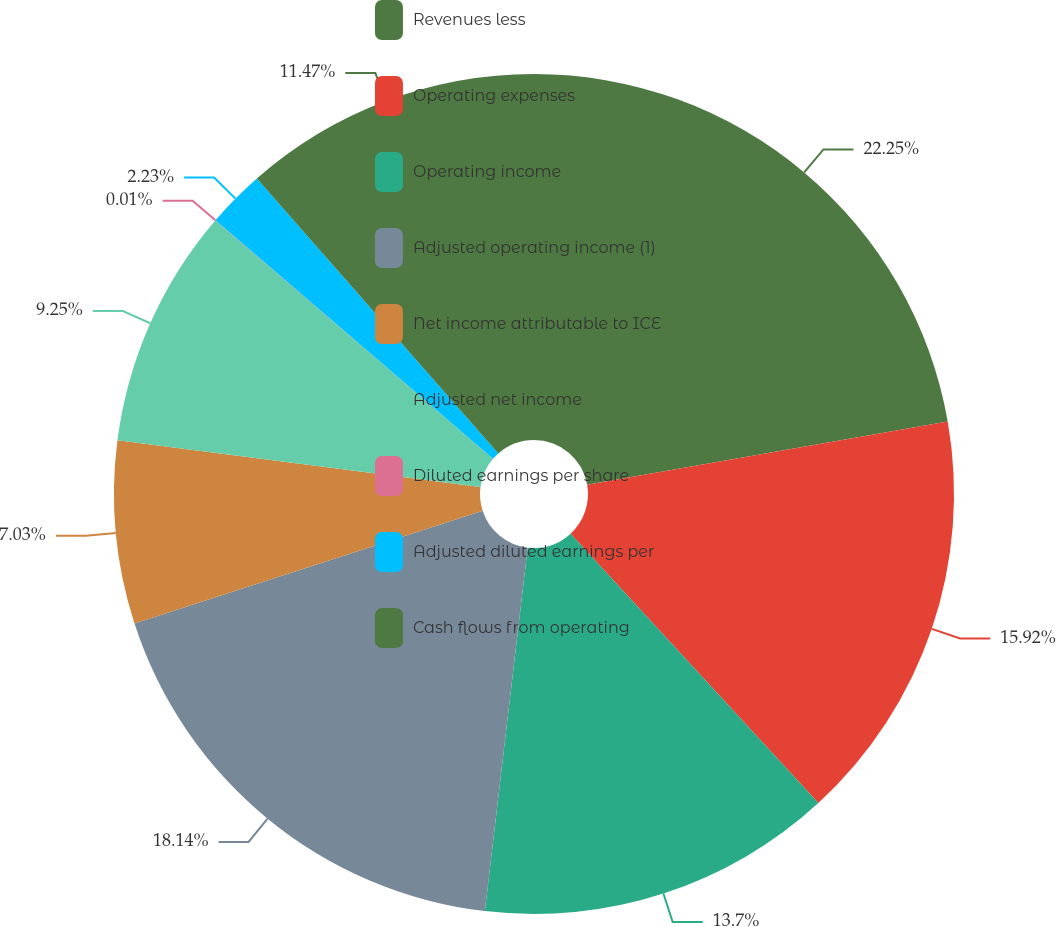<chart> <loc_0><loc_0><loc_500><loc_500><pie_chart><fcel>Revenues less<fcel>Operating expenses<fcel>Operating income<fcel>Adjusted operating income (1)<fcel>Net income attributable to ICE<fcel>Adjusted net income<fcel>Diluted earnings per share<fcel>Adjusted diluted earnings per<fcel>Cash flows from operating<nl><fcel>22.24%<fcel>15.92%<fcel>13.7%<fcel>18.14%<fcel>7.03%<fcel>9.25%<fcel>0.01%<fcel>2.23%<fcel>11.47%<nl></chart> 